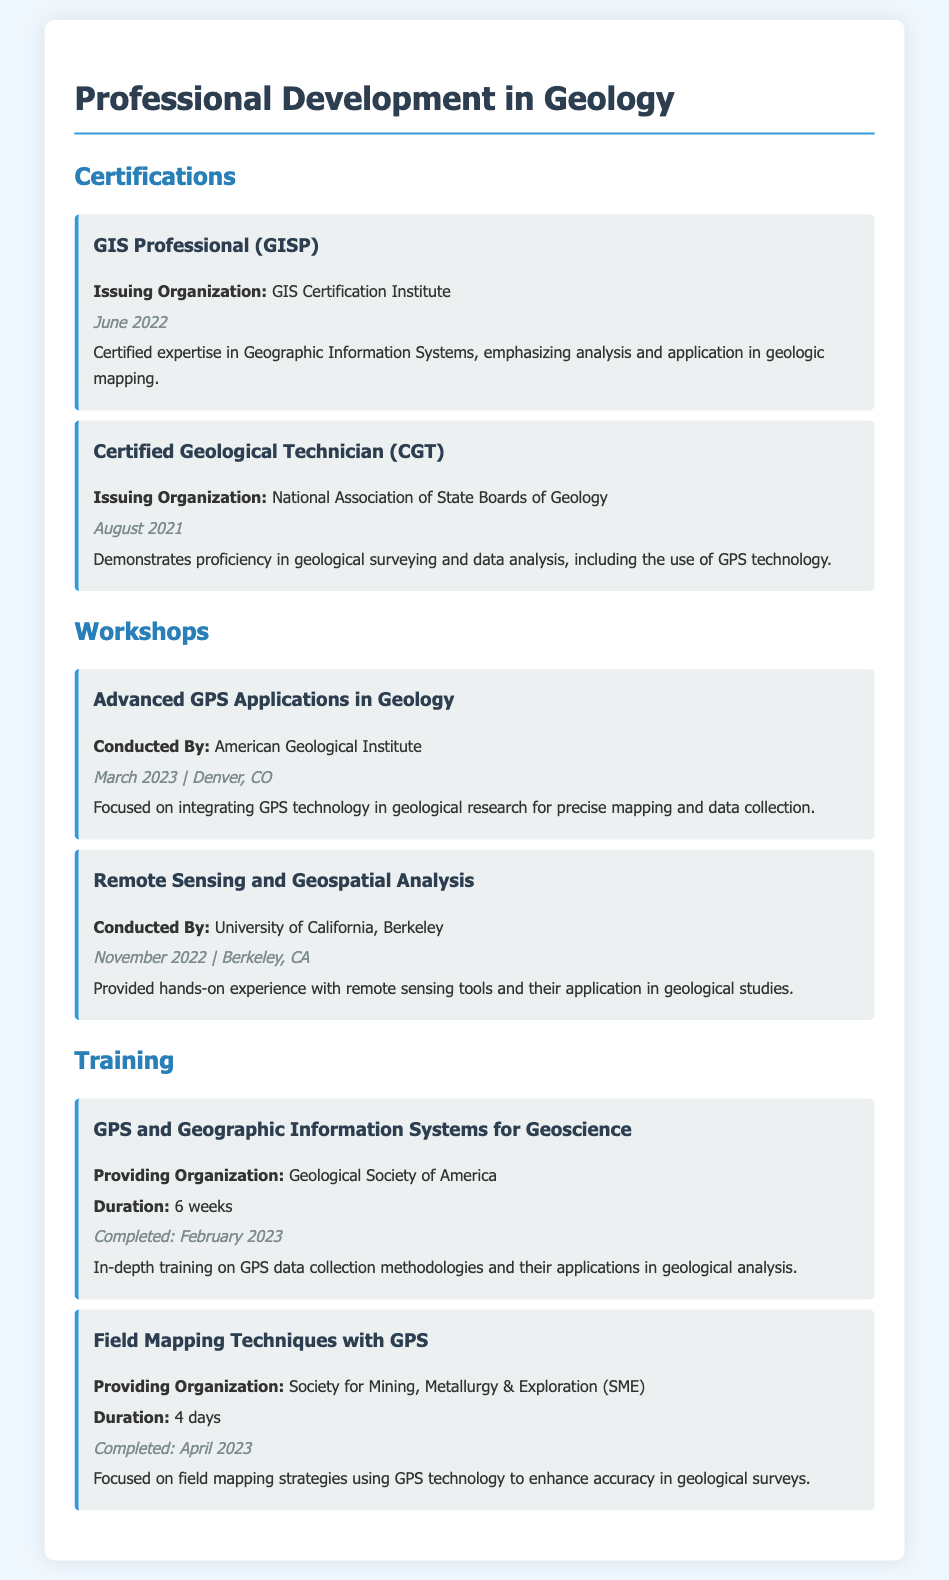what is the issuing organization for the GIS Professional certification? The document states that the GIS Professional certification is issued by the GIS Certification Institute.
Answer: GIS Certification Institute when was the Certified Geological Technician certification obtained? The document indicates that the Certified Geological Technician certification was obtained in August 2021.
Answer: August 2021 what is the title of the workshop conducted by the American Geological Institute? The document lists the workshop conducted by the American Geological Institute as "Advanced GPS Applications in Geology."
Answer: Advanced GPS Applications in Geology how long was the training on GPS and Geographic Information Systems for Geoscience? The document specifies that the training lasted for 6 weeks.
Answer: 6 weeks what is the focus of the workshop held in November 2022? The document mentions that the workshop held in November 2022 focused on remote sensing tools and their application in geological studies.
Answer: Remote sensing tools and their application in geological studies who conducted the training on Field Mapping Techniques with GPS? According to the document, the training was provided by the Society for Mining, Metallurgy & Exploration (SME).
Answer: Society for Mining, Metallurgy & Exploration (SME) what is the completion date for the GPS training program? The document states that the GPS training program was completed in February 2023.
Answer: February 2023 what type of document is this? This document is a resume that outlines professional development in geology.
Answer: Resume 